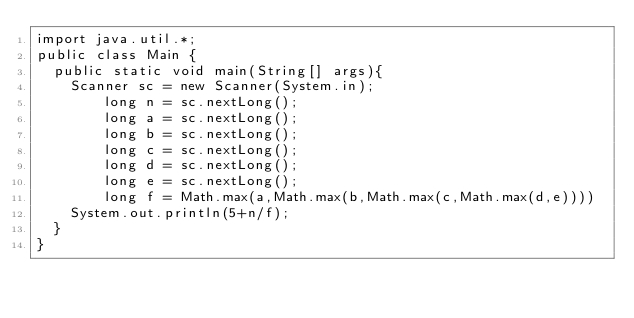Convert code to text. <code><loc_0><loc_0><loc_500><loc_500><_Java_>import java.util.*;
public class Main {
	public static void main(String[] args){
		Scanner sc = new Scanner(System.in);       
        long n = sc.nextLong();
        long a = sc.nextLong();
        long b = sc.nextLong();
        long c = sc.nextLong();
        long d = sc.nextLong();
        long e = sc.nextLong();
        long f = Math.max(a,Math.max(b,Math.max(c,Math.max(d,e))))
		System.out.println(5+n/f);
  }
}
</code> 